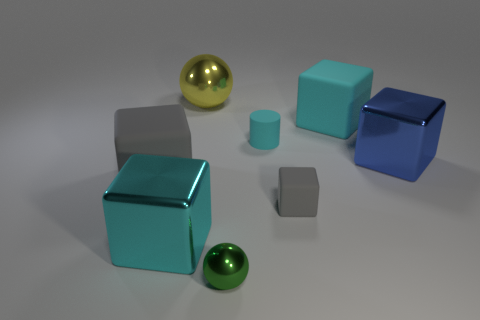Is the number of cyan things on the right side of the big cyan metal cube less than the number of large things that are to the left of the matte cylinder?
Offer a terse response. Yes. There is a large cyan matte thing; are there any cyan objects on the left side of it?
Offer a very short reply. Yes. What number of things are big metal things behind the tiny green sphere or large blocks to the right of the yellow metal thing?
Ensure brevity in your answer.  4. How many large shiny things have the same color as the small cylinder?
Provide a succinct answer. 1. There is another metallic object that is the same shape as the blue object; what is its color?
Your answer should be very brief. Cyan. There is a large thing that is both right of the green ball and on the left side of the big blue cube; what shape is it?
Offer a very short reply. Cube. Are there more large gray rubber blocks than small blue metal cylinders?
Keep it short and to the point. Yes. What is the material of the large gray thing?
Give a very brief answer. Rubber. The cyan metallic thing that is the same shape as the big cyan rubber object is what size?
Offer a terse response. Large. There is a large cyan thing that is left of the tiny gray object; is there a yellow ball in front of it?
Offer a very short reply. No. 